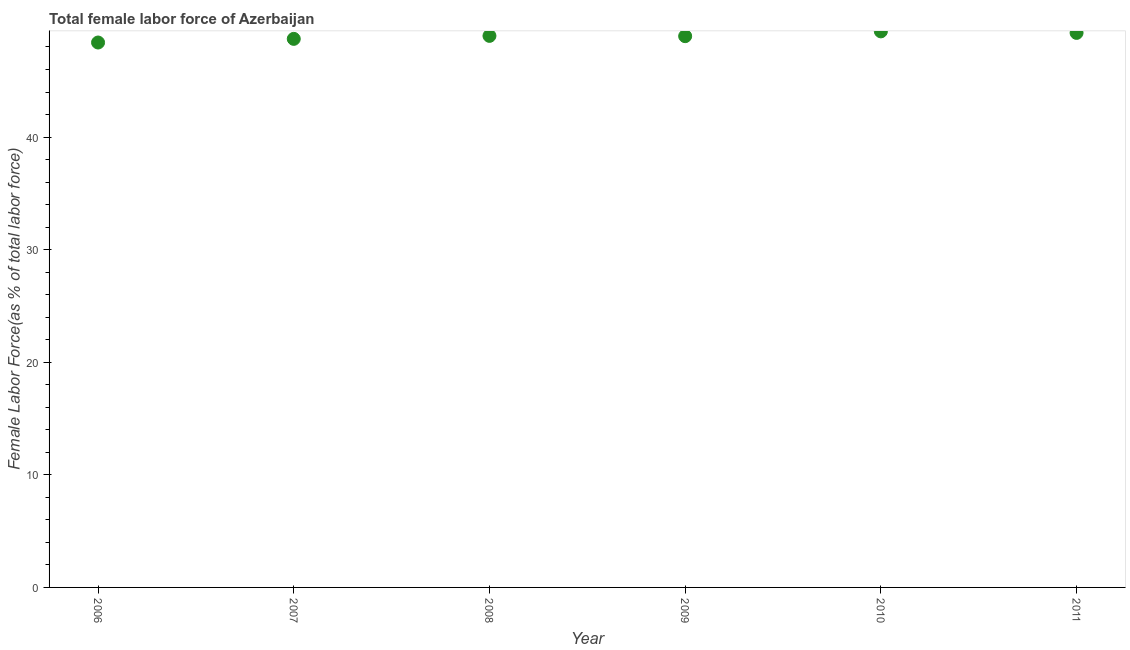What is the total female labor force in 2011?
Your response must be concise. 49.25. Across all years, what is the maximum total female labor force?
Give a very brief answer. 49.39. Across all years, what is the minimum total female labor force?
Ensure brevity in your answer.  48.4. What is the sum of the total female labor force?
Keep it short and to the point. 293.71. What is the difference between the total female labor force in 2009 and 2011?
Your response must be concise. -0.29. What is the average total female labor force per year?
Offer a very short reply. 48.95. What is the median total female labor force?
Keep it short and to the point. 48.97. Do a majority of the years between 2011 and 2010 (inclusive) have total female labor force greater than 10 %?
Ensure brevity in your answer.  No. What is the ratio of the total female labor force in 2008 to that in 2011?
Your answer should be compact. 0.99. Is the total female labor force in 2010 less than that in 2011?
Offer a terse response. No. What is the difference between the highest and the second highest total female labor force?
Your answer should be compact. 0.13. Is the sum of the total female labor force in 2006 and 2008 greater than the maximum total female labor force across all years?
Your answer should be compact. Yes. What is the difference between the highest and the lowest total female labor force?
Your answer should be compact. 0.99. In how many years, is the total female labor force greater than the average total female labor force taken over all years?
Your response must be concise. 4. Are the values on the major ticks of Y-axis written in scientific E-notation?
Offer a very short reply. No. Does the graph contain any zero values?
Offer a terse response. No. Does the graph contain grids?
Provide a short and direct response. No. What is the title of the graph?
Keep it short and to the point. Total female labor force of Azerbaijan. What is the label or title of the X-axis?
Provide a short and direct response. Year. What is the label or title of the Y-axis?
Offer a terse response. Female Labor Force(as % of total labor force). What is the Female Labor Force(as % of total labor force) in 2006?
Your answer should be compact. 48.4. What is the Female Labor Force(as % of total labor force) in 2007?
Provide a short and direct response. 48.72. What is the Female Labor Force(as % of total labor force) in 2008?
Your response must be concise. 48.99. What is the Female Labor Force(as % of total labor force) in 2009?
Make the answer very short. 48.96. What is the Female Labor Force(as % of total labor force) in 2010?
Your answer should be compact. 49.39. What is the Female Labor Force(as % of total labor force) in 2011?
Offer a very short reply. 49.25. What is the difference between the Female Labor Force(as % of total labor force) in 2006 and 2007?
Your response must be concise. -0.32. What is the difference between the Female Labor Force(as % of total labor force) in 2006 and 2008?
Make the answer very short. -0.59. What is the difference between the Female Labor Force(as % of total labor force) in 2006 and 2009?
Your answer should be very brief. -0.56. What is the difference between the Female Labor Force(as % of total labor force) in 2006 and 2010?
Give a very brief answer. -0.99. What is the difference between the Female Labor Force(as % of total labor force) in 2006 and 2011?
Your response must be concise. -0.85. What is the difference between the Female Labor Force(as % of total labor force) in 2007 and 2008?
Keep it short and to the point. -0.27. What is the difference between the Female Labor Force(as % of total labor force) in 2007 and 2009?
Give a very brief answer. -0.24. What is the difference between the Female Labor Force(as % of total labor force) in 2007 and 2010?
Ensure brevity in your answer.  -0.66. What is the difference between the Female Labor Force(as % of total labor force) in 2007 and 2011?
Your answer should be compact. -0.53. What is the difference between the Female Labor Force(as % of total labor force) in 2008 and 2009?
Your response must be concise. 0.03. What is the difference between the Female Labor Force(as % of total labor force) in 2008 and 2010?
Give a very brief answer. -0.4. What is the difference between the Female Labor Force(as % of total labor force) in 2008 and 2011?
Make the answer very short. -0.27. What is the difference between the Female Labor Force(as % of total labor force) in 2009 and 2010?
Provide a succinct answer. -0.43. What is the difference between the Female Labor Force(as % of total labor force) in 2009 and 2011?
Provide a short and direct response. -0.29. What is the difference between the Female Labor Force(as % of total labor force) in 2010 and 2011?
Give a very brief answer. 0.13. What is the ratio of the Female Labor Force(as % of total labor force) in 2006 to that in 2007?
Make the answer very short. 0.99. What is the ratio of the Female Labor Force(as % of total labor force) in 2006 to that in 2011?
Keep it short and to the point. 0.98. What is the ratio of the Female Labor Force(as % of total labor force) in 2007 to that in 2009?
Provide a short and direct response. 0.99. What is the ratio of the Female Labor Force(as % of total labor force) in 2007 to that in 2011?
Offer a terse response. 0.99. What is the ratio of the Female Labor Force(as % of total labor force) in 2008 to that in 2009?
Ensure brevity in your answer.  1. What is the ratio of the Female Labor Force(as % of total labor force) in 2008 to that in 2010?
Your answer should be very brief. 0.99. What is the ratio of the Female Labor Force(as % of total labor force) in 2008 to that in 2011?
Make the answer very short. 0.99. What is the ratio of the Female Labor Force(as % of total labor force) in 2009 to that in 2010?
Provide a succinct answer. 0.99. What is the ratio of the Female Labor Force(as % of total labor force) in 2009 to that in 2011?
Make the answer very short. 0.99. 